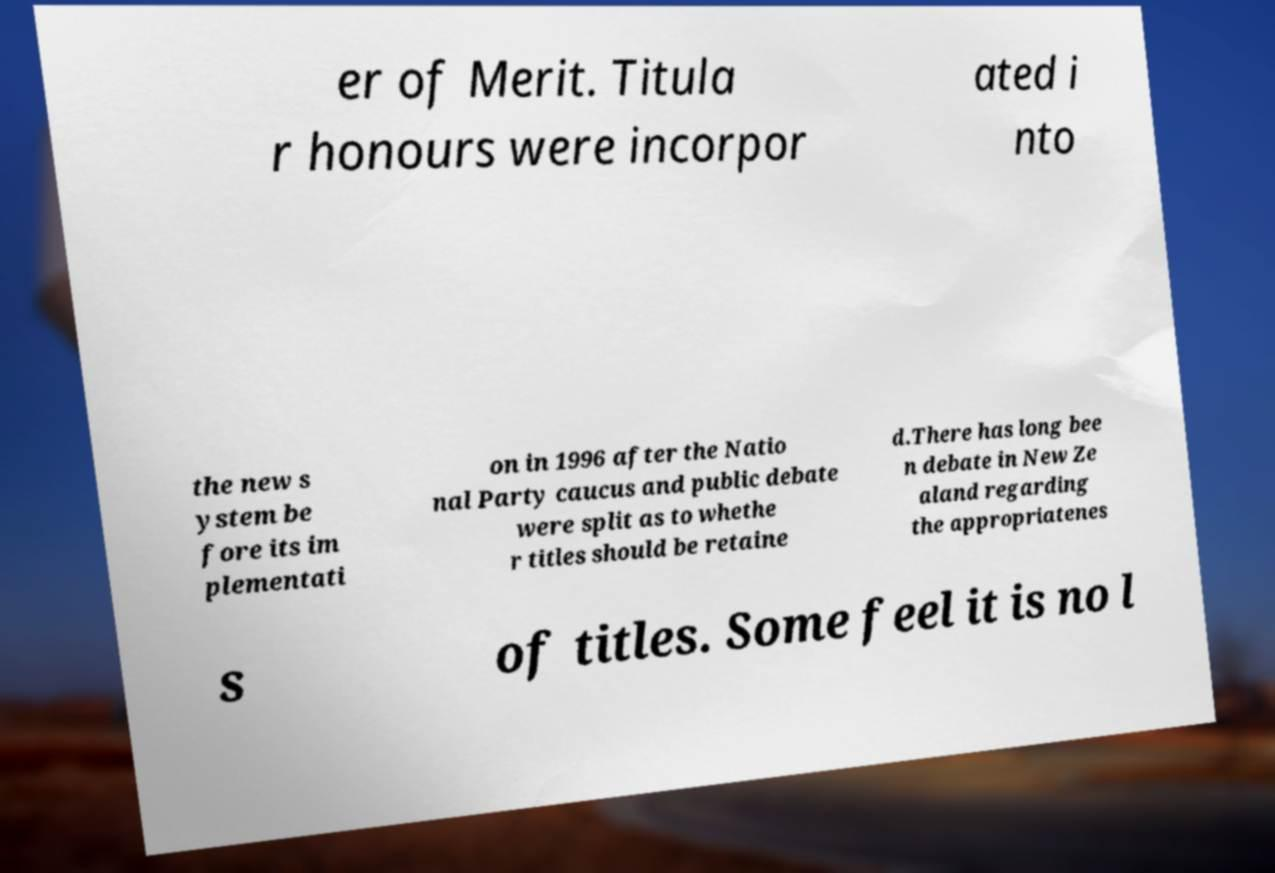Can you accurately transcribe the text from the provided image for me? er of Merit. Titula r honours were incorpor ated i nto the new s ystem be fore its im plementati on in 1996 after the Natio nal Party caucus and public debate were split as to whethe r titles should be retaine d.There has long bee n debate in New Ze aland regarding the appropriatenes s of titles. Some feel it is no l 